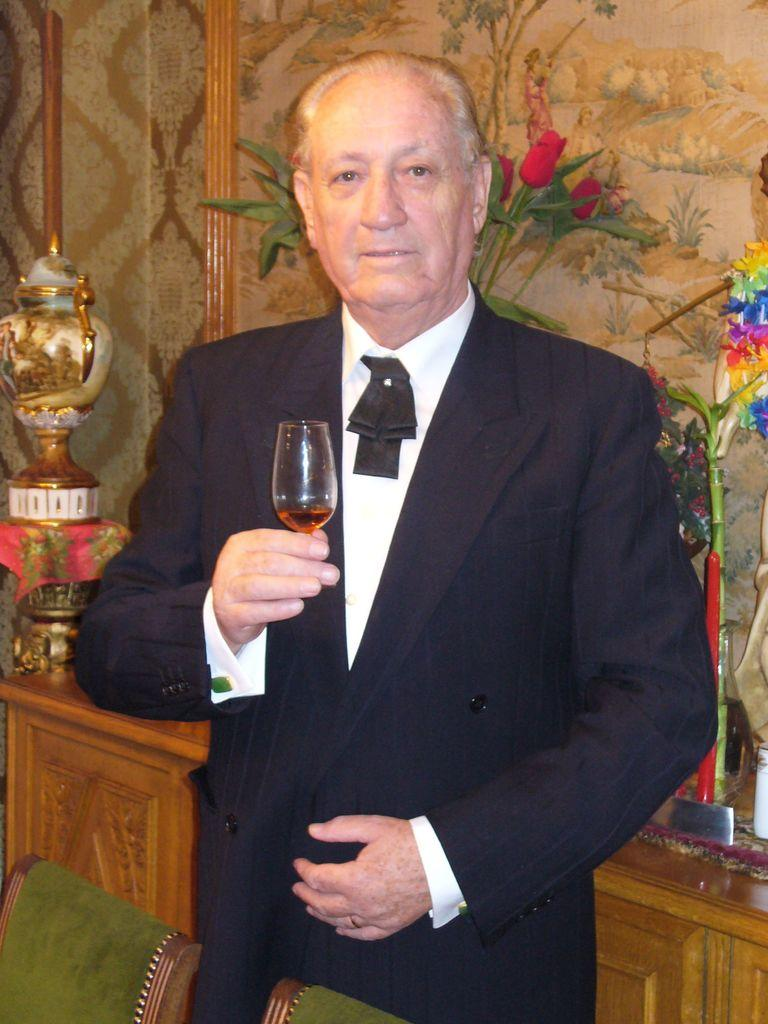Who is present in the image? There is a man in the image. What is the man holding in the image? The man is holding a wine glass. What furniture is visible in front of the man? There are two chairs in front of the man. What can be seen on the wall behind the man? There are frames on the wall behind the man. What type of storage furniture is visible behind the man? There are cupboards behind the man. How does the man twist his underwear in the image? There is no mention of underwear in the image, and the man is not performing any twisting actions. 